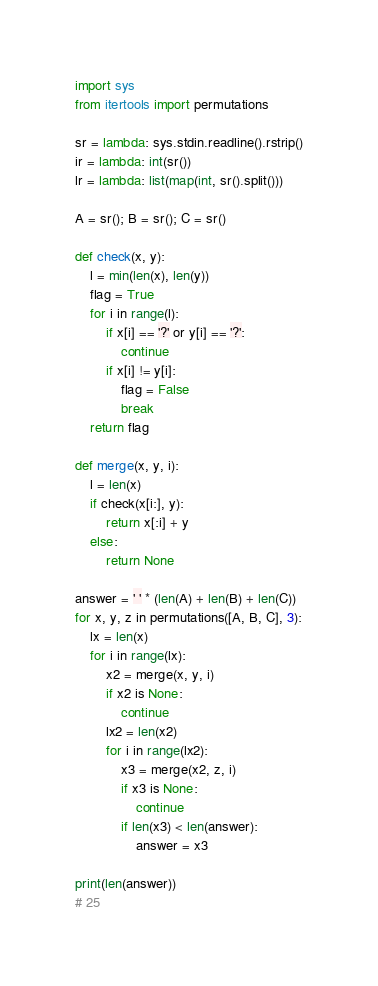<code> <loc_0><loc_0><loc_500><loc_500><_Python_>import sys
from itertools import permutations

sr = lambda: sys.stdin.readline().rstrip()
ir = lambda: int(sr())
lr = lambda: list(map(int, sr().split()))

A = sr(); B = sr(); C = sr()

def check(x, y):
    l = min(len(x), len(y))
    flag = True
    for i in range(l):
        if x[i] == '?' or y[i] == '?':
            continue
        if x[i] != y[i]:
            flag = False
            break
    return flag

def merge(x, y, i):
    l = len(x)
    if check(x[i:], y):
        return x[:i] + y
    else:
        return None

answer = ' ' * (len(A) + len(B) + len(C))
for x, y, z in permutations([A, B, C], 3):
    lx = len(x)
    for i in range(lx):
        x2 = merge(x, y, i)
        if x2 is None:
            continue
        lx2 = len(x2)
        for i in range(lx2):
            x3 = merge(x2, z, i)
            if x3 is None:
                continue
            if len(x3) < len(answer):
                answer = x3
      
print(len(answer))
# 25</code> 